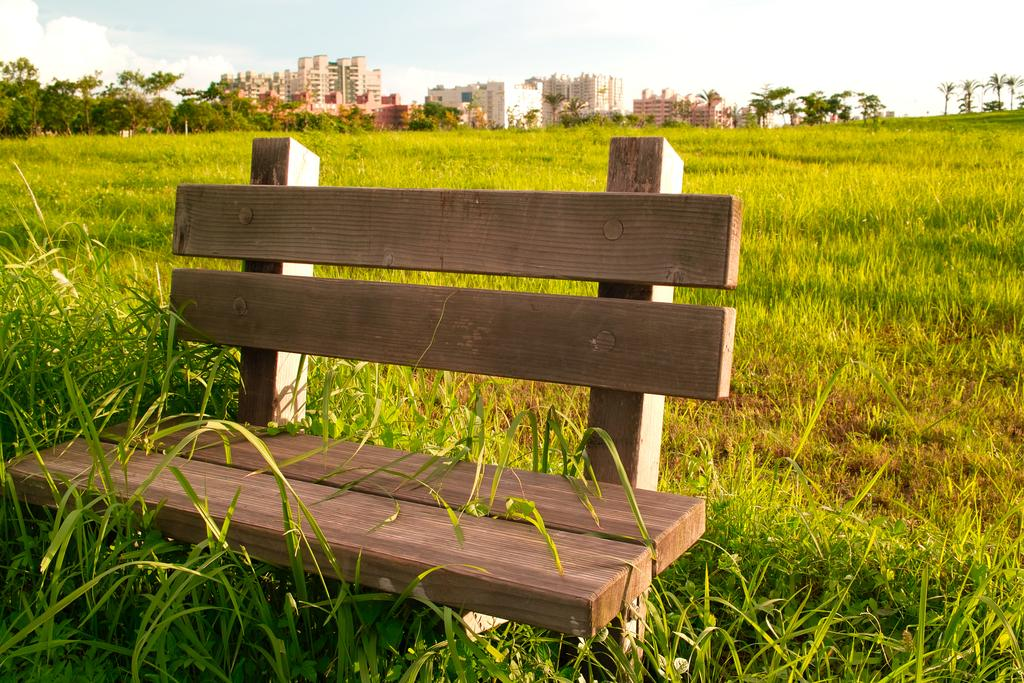What type of seating is present in the image? There is a bench in the image. What type of vegetation is present in the image? There is grass in the image. What type of natural structures are present in the image? There are trees in the image. What type of man-made structures are present in the image? There are buildings in the image. What is visible at the top of the image? The sky is visible at the top of the image. Where is the playground located in the image? There is no playground present in the image. What type of string is visible in the image? There is no string visible in the image. 